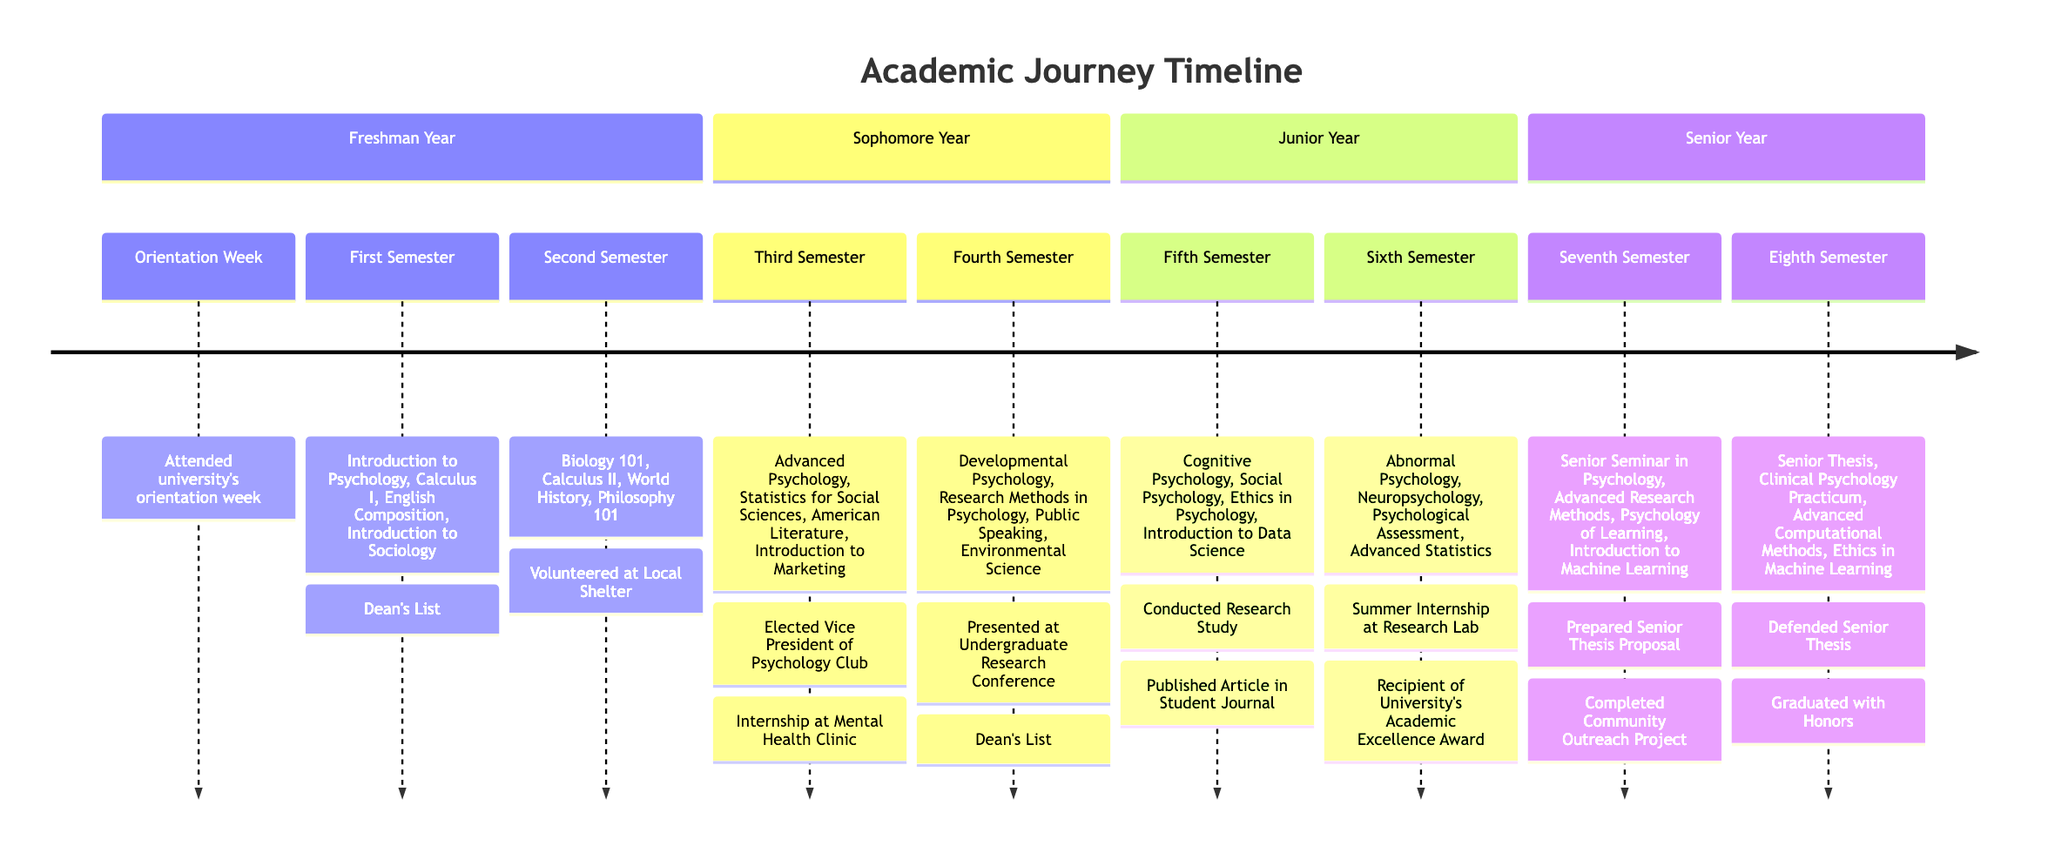What was the first milestone in the Freshman Year? The first milestone listed under Freshman Year is "Orientation Week." This can be found right at the beginning of that section.
Answer: Orientation Week How many semesters are there in the Sophomore Year? In the diagram, Sophomore Year has two semesters listed: Third Semester and Fourth Semester. Counting these gives a total of two semesters.
Answer: 2 What courses were taken during the Sixth Semester? The Sixth Semester lists four courses: Abnormal Psychology, Neuropsychology, Psychological Assessment, and Advanced Statistics. These can be found listed in that specific section of the diagram.
Answer: Abnormal Psychology, Neuropsychology, Psychological Assessment, Advanced Statistics Which achievement is associated with the Third Semester? The achievement for the Third Semester is "Elected Vice President of Psychology Club." This specific achievement is mentioned directly after the course list for that semester.
Answer: Elected Vice President of Psychology Club In which semester did the student defend their Senior Thesis? The Senior Thesis was defended in the Eighth Semester, as stated in the diagram's description for that semester.
Answer: Eighth Semester What unique achievement is listed under Junior Year? The Junior Year lists an achievement of "Published Article in Student Journal" under the fifth semester. This is one of the unique accomplishments during that year.
Answer: Published Article in Student Journal What is the last course listed for the Senior Year? The last course listed in the diagram for the Senior Year is "Ethics in Machine Learning," which is found under the Eighth Semester.
Answer: Ethics in Machine Learning Which year has an internship at a Mental Health Clinic? The internship at a Mental Health Clinic is listed under the Third Semester during the Sophomore Year, as indicated in the corresponding section of the diagram.
Answer: Sophomore Year What major accomplishment occurred in the Seventh Semester? In the Seventh Semester, the student prepared a Senior Thesis Proposal, which is noted as a significant milestone in that semester.
Answer: Prepared Senior Thesis Proposal 